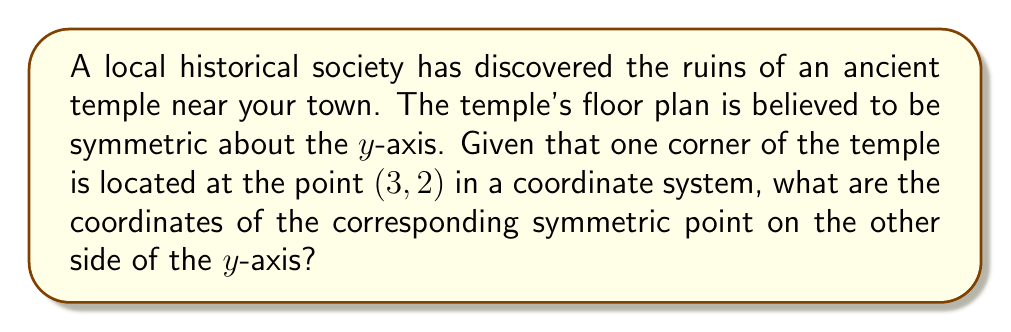Teach me how to tackle this problem. Let's approach this step-by-step:

1) The temple is symmetric about the y-axis. This means we need to perform a reflection over the y-axis.

2) For a reflection over the y-axis, the transformation is:
   $$(x, y) \rightarrow (-x, y)$$

3) The given point is (3, 2). Let's apply the transformation:
   $$(3, 2) \rightarrow (-3, 2)$$

4) The x-coordinate changes sign, while the y-coordinate remains the same.

5) Therefore, the symmetric point will have coordinates (-3, 2).

This transformation can be visualized as follows:

[asy]
import geometry;

size(200);
defaultpen(fontsize(10pt));

draw((-4,0)--(4,0),arrow=Arrow(TeXHead));
draw((0,-1)--(0,3),arrow=Arrow(TeXHead));

dot((3,2));
dot((-3,2));

label("(3, 2)", (3,2), E);
label("(-3, 2)", (-3,2), W);
label("x", (4,0), E);
label("y", (0,3), N);

draw((0,0)--(3,2),dashed);
draw((0,0)--(-3,2),dashed);
[/asy]

This reflection preserves the historical symmetry of the ancient temple's floor plan.
Answer: (-3, 2) 